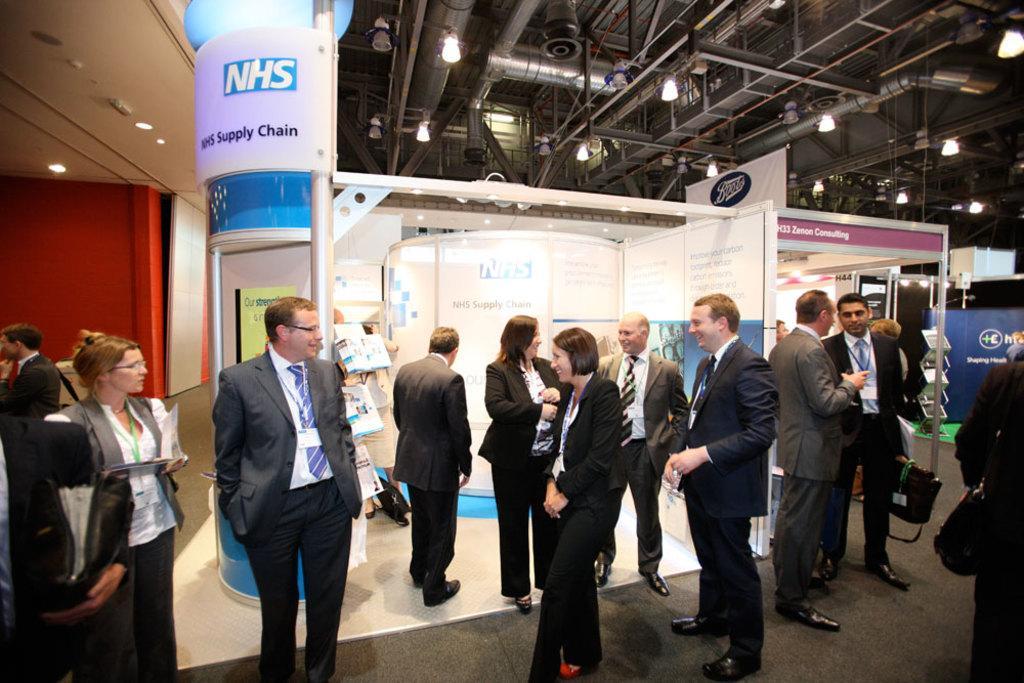How would you summarize this image in a sentence or two? Here people are standing, these are advertisement boards, here there are lights hanging to the shed. 